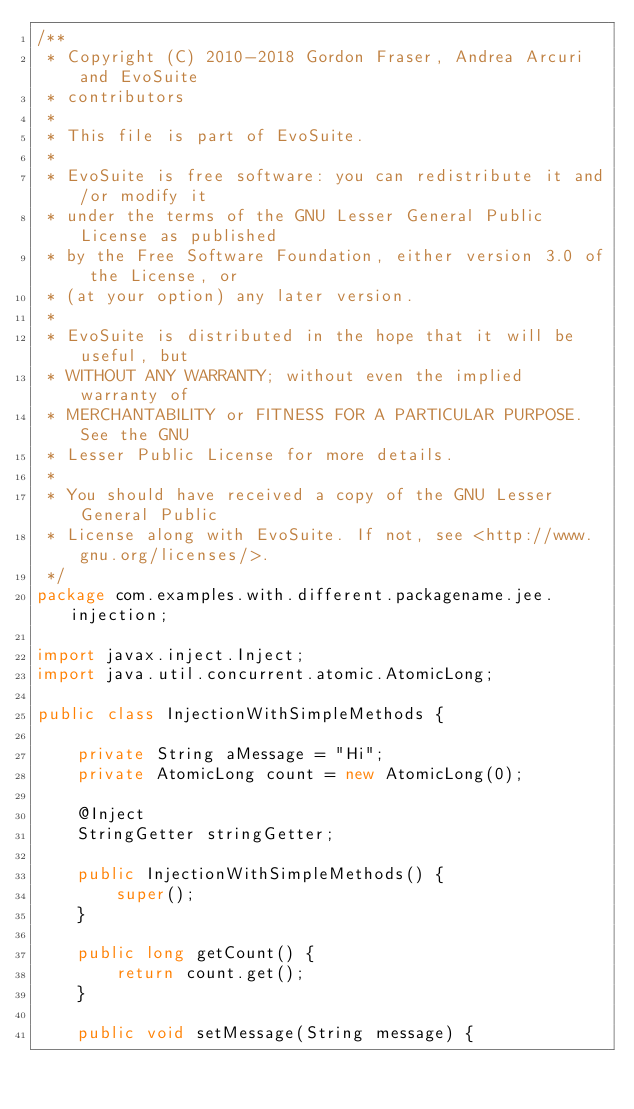Convert code to text. <code><loc_0><loc_0><loc_500><loc_500><_Java_>/**
 * Copyright (C) 2010-2018 Gordon Fraser, Andrea Arcuri and EvoSuite
 * contributors
 *
 * This file is part of EvoSuite.
 *
 * EvoSuite is free software: you can redistribute it and/or modify it
 * under the terms of the GNU Lesser General Public License as published
 * by the Free Software Foundation, either version 3.0 of the License, or
 * (at your option) any later version.
 *
 * EvoSuite is distributed in the hope that it will be useful, but
 * WITHOUT ANY WARRANTY; without even the implied warranty of
 * MERCHANTABILITY or FITNESS FOR A PARTICULAR PURPOSE. See the GNU
 * Lesser Public License for more details.
 *
 * You should have received a copy of the GNU Lesser General Public
 * License along with EvoSuite. If not, see <http://www.gnu.org/licenses/>.
 */
package com.examples.with.different.packagename.jee.injection;

import javax.inject.Inject;
import java.util.concurrent.atomic.AtomicLong;

public class InjectionWithSimpleMethods {

    private String aMessage = "Hi";
    private AtomicLong count = new AtomicLong(0);

    @Inject
    StringGetter stringGetter;

    public InjectionWithSimpleMethods() {
        super();
    }

    public long getCount() {
        return count.get();
    }

    public void setMessage(String message) {</code> 